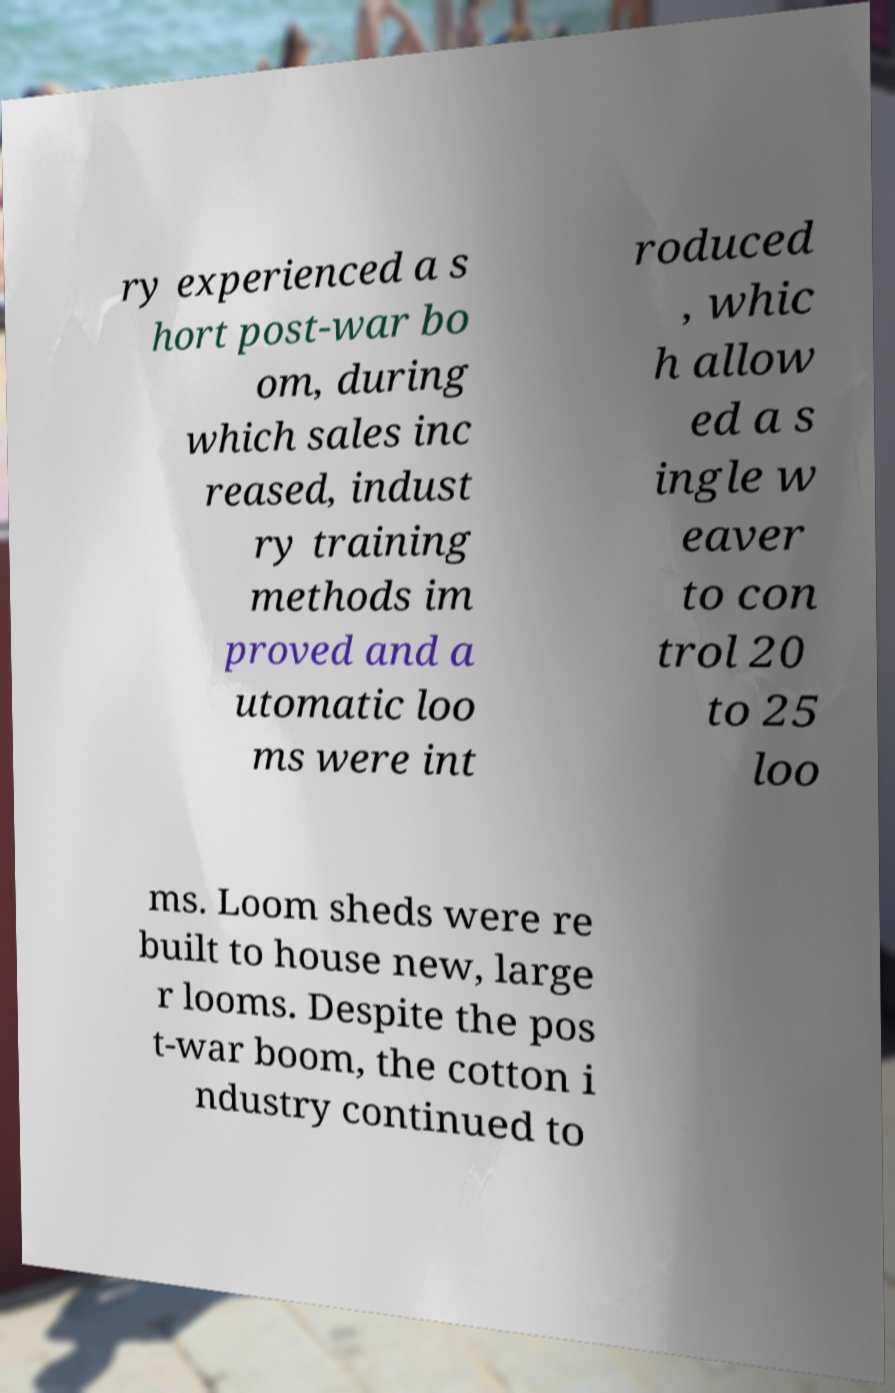What messages or text are displayed in this image? I need them in a readable, typed format. ry experienced a s hort post-war bo om, during which sales inc reased, indust ry training methods im proved and a utomatic loo ms were int roduced , whic h allow ed a s ingle w eaver to con trol 20 to 25 loo ms. Loom sheds were re built to house new, large r looms. Despite the pos t-war boom, the cotton i ndustry continued to 